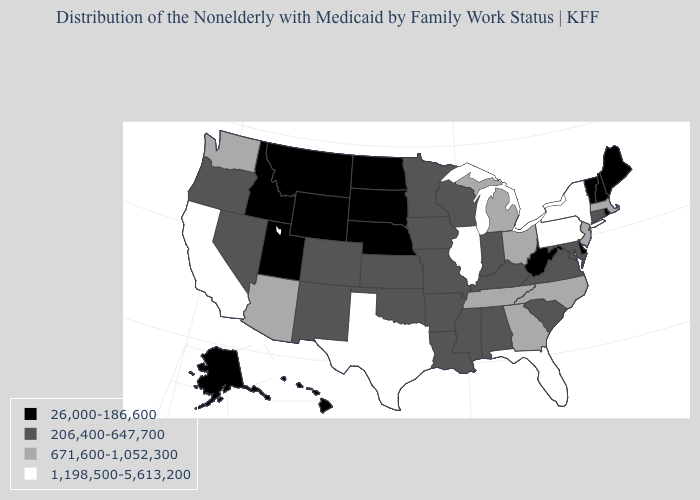What is the value of California?
Quick response, please. 1,198,500-5,613,200. Does the first symbol in the legend represent the smallest category?
Answer briefly. Yes. Among the states that border Montana , which have the lowest value?
Be succinct. Idaho, North Dakota, South Dakota, Wyoming. Name the states that have a value in the range 26,000-186,600?
Write a very short answer. Alaska, Delaware, Hawaii, Idaho, Maine, Montana, Nebraska, New Hampshire, North Dakota, Rhode Island, South Dakota, Utah, Vermont, West Virginia, Wyoming. Name the states that have a value in the range 1,198,500-5,613,200?
Answer briefly. California, Florida, Illinois, New York, Pennsylvania, Texas. What is the value of Mississippi?
Keep it brief. 206,400-647,700. Which states have the highest value in the USA?
Be succinct. California, Florida, Illinois, New York, Pennsylvania, Texas. Among the states that border Connecticut , does New York have the highest value?
Be succinct. Yes. Name the states that have a value in the range 1,198,500-5,613,200?
Answer briefly. California, Florida, Illinois, New York, Pennsylvania, Texas. What is the lowest value in the USA?
Keep it brief. 26,000-186,600. What is the value of Maine?
Keep it brief. 26,000-186,600. Name the states that have a value in the range 26,000-186,600?
Answer briefly. Alaska, Delaware, Hawaii, Idaho, Maine, Montana, Nebraska, New Hampshire, North Dakota, Rhode Island, South Dakota, Utah, Vermont, West Virginia, Wyoming. What is the value of North Dakota?
Keep it brief. 26,000-186,600. Does Nebraska have the lowest value in the MidWest?
Keep it brief. Yes. Which states have the lowest value in the Northeast?
Short answer required. Maine, New Hampshire, Rhode Island, Vermont. 